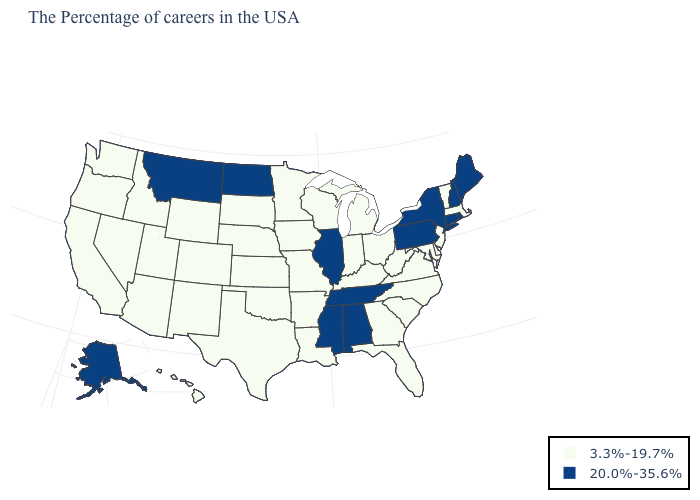Among the states that border Mississippi , does Louisiana have the lowest value?
Be succinct. Yes. Which states have the lowest value in the West?
Keep it brief. Wyoming, Colorado, New Mexico, Utah, Arizona, Idaho, Nevada, California, Washington, Oregon, Hawaii. Name the states that have a value in the range 20.0%-35.6%?
Keep it brief. Maine, Rhode Island, New Hampshire, Connecticut, New York, Pennsylvania, Alabama, Tennessee, Illinois, Mississippi, North Dakota, Montana, Alaska. Does South Carolina have the same value as Vermont?
Quick response, please. Yes. Which states have the lowest value in the South?
Short answer required. Delaware, Maryland, Virginia, North Carolina, South Carolina, West Virginia, Florida, Georgia, Kentucky, Louisiana, Arkansas, Oklahoma, Texas. Name the states that have a value in the range 3.3%-19.7%?
Short answer required. Massachusetts, Vermont, New Jersey, Delaware, Maryland, Virginia, North Carolina, South Carolina, West Virginia, Ohio, Florida, Georgia, Michigan, Kentucky, Indiana, Wisconsin, Louisiana, Missouri, Arkansas, Minnesota, Iowa, Kansas, Nebraska, Oklahoma, Texas, South Dakota, Wyoming, Colorado, New Mexico, Utah, Arizona, Idaho, Nevada, California, Washington, Oregon, Hawaii. Does New Hampshire have the lowest value in the Northeast?
Quick response, please. No. How many symbols are there in the legend?
Be succinct. 2. Name the states that have a value in the range 3.3%-19.7%?
Concise answer only. Massachusetts, Vermont, New Jersey, Delaware, Maryland, Virginia, North Carolina, South Carolina, West Virginia, Ohio, Florida, Georgia, Michigan, Kentucky, Indiana, Wisconsin, Louisiana, Missouri, Arkansas, Minnesota, Iowa, Kansas, Nebraska, Oklahoma, Texas, South Dakota, Wyoming, Colorado, New Mexico, Utah, Arizona, Idaho, Nevada, California, Washington, Oregon, Hawaii. What is the value of Missouri?
Answer briefly. 3.3%-19.7%. Name the states that have a value in the range 20.0%-35.6%?
Concise answer only. Maine, Rhode Island, New Hampshire, Connecticut, New York, Pennsylvania, Alabama, Tennessee, Illinois, Mississippi, North Dakota, Montana, Alaska. What is the value of Indiana?
Answer briefly. 3.3%-19.7%. Which states have the lowest value in the West?
Give a very brief answer. Wyoming, Colorado, New Mexico, Utah, Arizona, Idaho, Nevada, California, Washington, Oregon, Hawaii. What is the value of New York?
Be succinct. 20.0%-35.6%. What is the value of Connecticut?
Concise answer only. 20.0%-35.6%. 